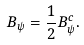<formula> <loc_0><loc_0><loc_500><loc_500>B _ { \psi } = \frac { 1 } { 2 } B _ { \psi } ^ { c } .</formula> 